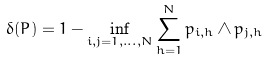<formula> <loc_0><loc_0><loc_500><loc_500>\delta ( P ) = 1 - \inf _ { i , j = 1 , \dots , N } \sum _ { h = 1 } ^ { N } p _ { i , h } \wedge p _ { j , h }</formula> 